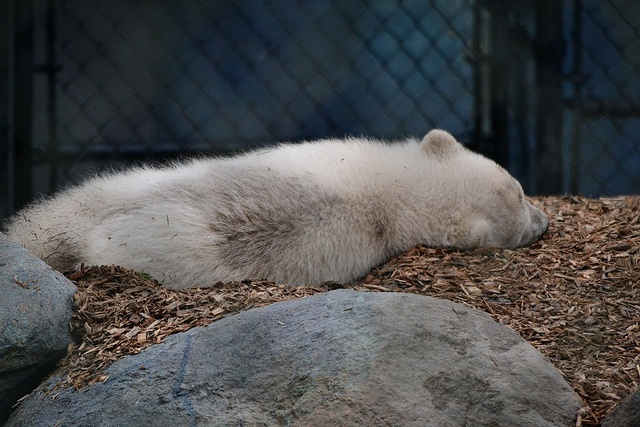Describe the objects in this image and their specific colors. I can see a bear in black, darkgray, gray, and lightgray tones in this image. 